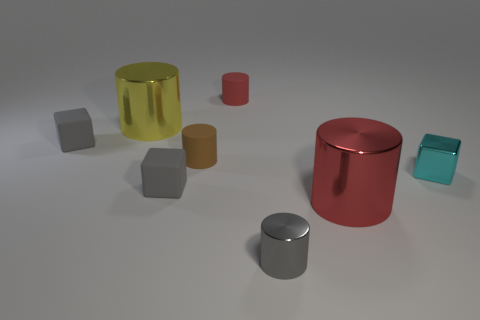What shape is the object that is the same size as the yellow cylinder?
Provide a short and direct response. Cylinder. Do the big yellow thing and the tiny brown cylinder have the same material?
Give a very brief answer. No. What number of shiny objects are either big brown cubes or brown cylinders?
Ensure brevity in your answer.  0. Do the large metallic cylinder that is right of the yellow thing and the tiny metallic cube have the same color?
Ensure brevity in your answer.  No. What shape is the gray object that is to the right of the tiny cylinder left of the tiny red matte cylinder?
Offer a very short reply. Cylinder. How many objects are either cylinders right of the red matte cylinder or big shiny cylinders that are to the left of the small red cylinder?
Your answer should be compact. 3. There is a small thing that is made of the same material as the cyan cube; what shape is it?
Ensure brevity in your answer.  Cylinder. Are there any other things that have the same color as the tiny shiny cylinder?
Your answer should be compact. Yes. What material is the large red object that is the same shape as the tiny red rubber thing?
Ensure brevity in your answer.  Metal. How many other objects are the same size as the yellow metallic thing?
Give a very brief answer. 1. 